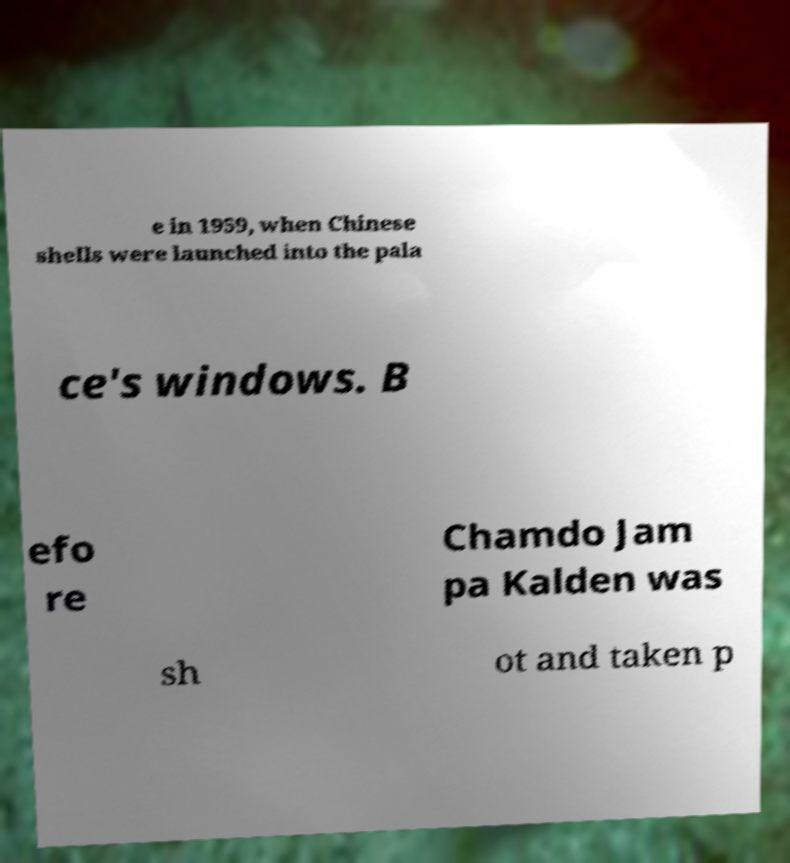There's text embedded in this image that I need extracted. Can you transcribe it verbatim? e in 1959, when Chinese shells were launched into the pala ce's windows. B efo re Chamdo Jam pa Kalden was sh ot and taken p 